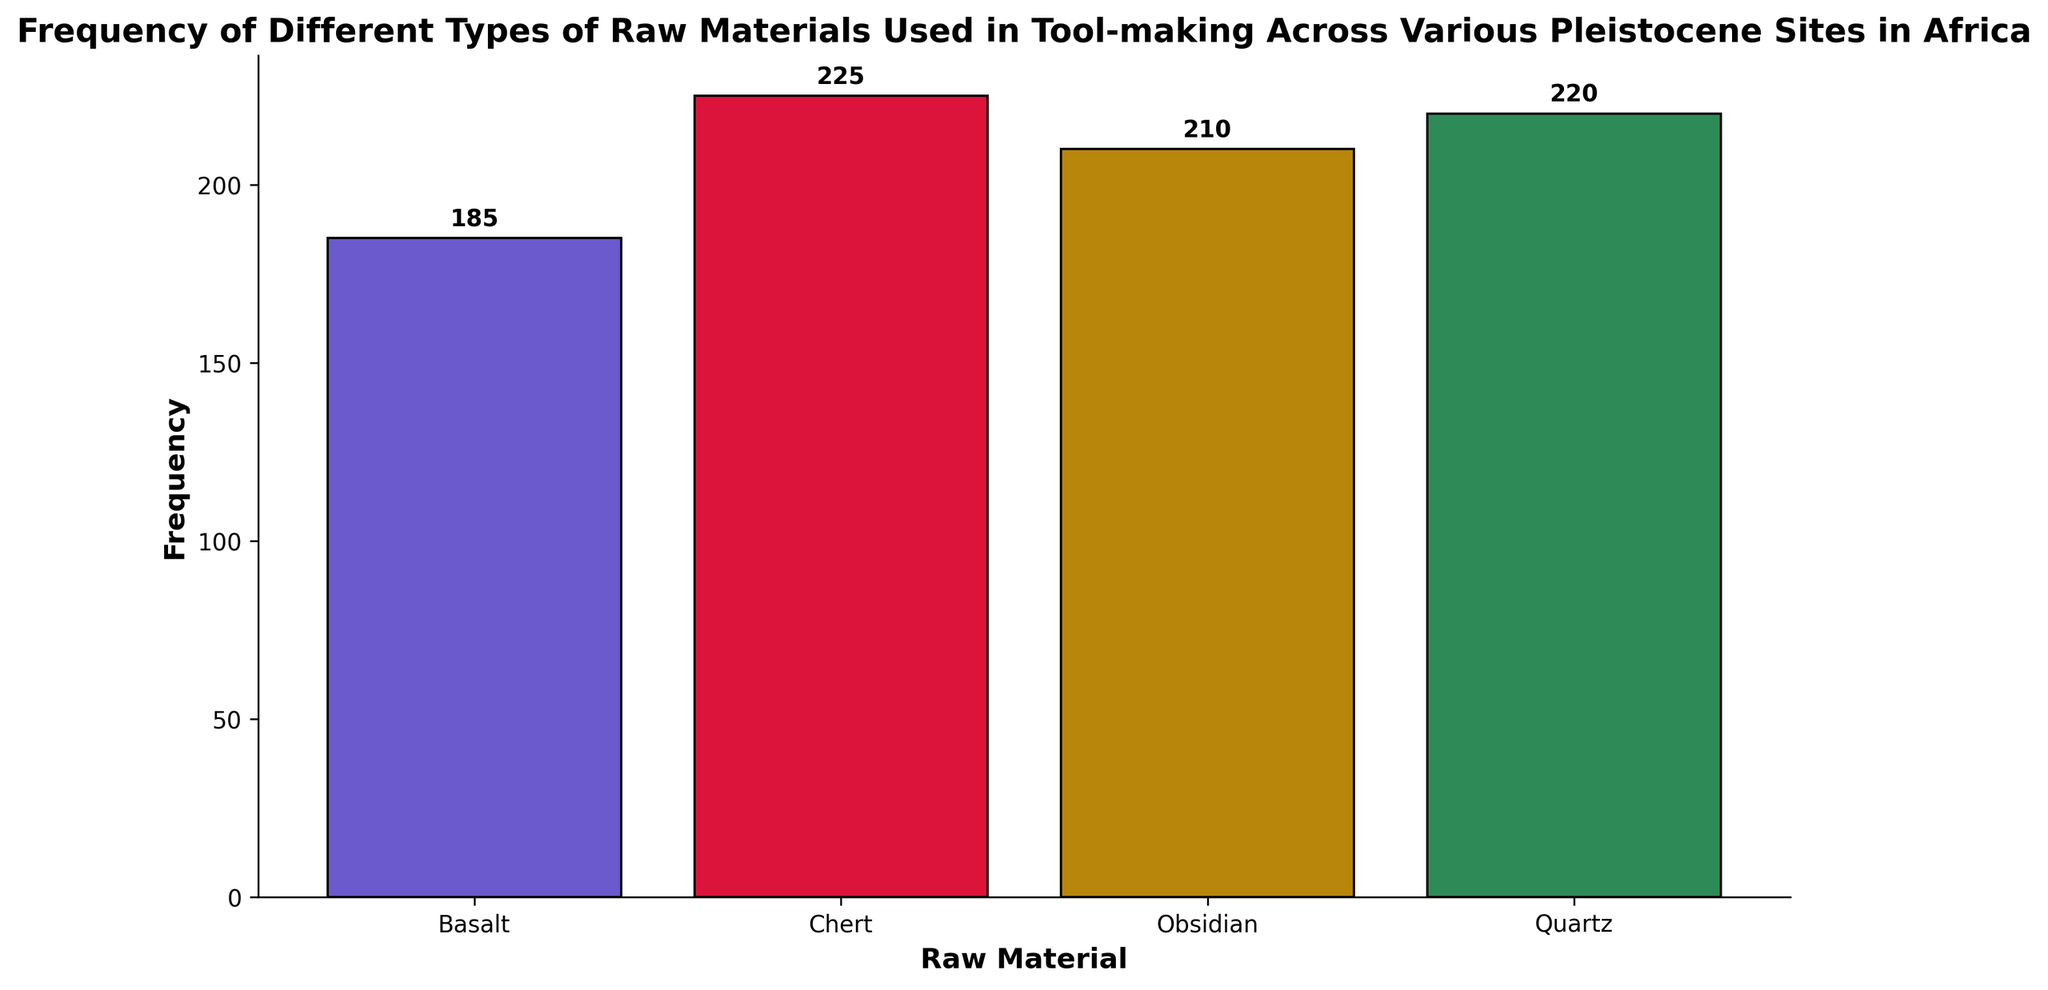What is the total frequency of Chert used across all sites? To find the total frequency of Chert, we sum up the Chert values from each site: 45 (Olduvai Gorge) + 50 (Koobi Fora) + 25 (Gademotta) + 30 (Dmanisi) + 40 (Blombos Cave) + 35 (Wonderwerk Cave). The result is 225.
Answer: 225 Which raw material has the highest frequency overall? Reviewing the heights of the bars representing each raw material, Obsidian has the highest overall frequency with the tallest bar at 210.
Answer: Obsidian How many more times is Obsidian used compared to Quartz? Obsidian's frequency is 210, and Quartz's frequency is 220. However, this is slightly less than Quartz, meaning Quartz is used more than Obsidian by 10 units.
Answer: Quartz has a frequency 10 units higher By how much is the frequency of Basalt greater in Dmanisi compared to Gademotta? From the histogram, we see that Dmanisi has a Basalt frequency of 40 and Gademotta has 20. Subtracting these values, we find that Basalt usage in Dmanisi is greater by 20 units.
Answer: 20 What is the average frequency of types of raw materials used in Gademotta? Summing the frequencies of Chert (25), Obsidian (55), Quartz (45), and Basalt (20) in Gademotta gives a total of 145. Dividing this total by the number of raw materials (4) gives an average of 36.25.
Answer: 36.25 Which site uses the least amount of Obsidian, and what is its frequency? By inspecting the histogram, Blombos Cave has the shortest bar for Obsidian with a frequency of 20, the least among the sites.
Answer: Blombos Cave, 20 What is the difference in frequency between the most and least used raw materials? The most used material is Quartz with a frequency of 220, and the least used is Basalt with a frequency of 185. The difference is 220 - 185 = 35 units.
Answer: 35 What is the combined frequency of Quartz and Obsidian? By adding the total frequencies of Quartz (220) and Obsidian (210), we find the combined frequency is 430.
Answer: 430 Which raw material has the second highest overall usage? The histogram bars indicate that Quartz has the highest frequency (220), making Obsidian (210) the second highest.
Answer: Obsidian Is the frequency of Quartz higher in Blombos Cave than in Olduvai Gorge? Yes, according to the histogram, Quartz frequency in Blombos Cave (50) is higher than in Olduvai Gorge (20).
Answer: Yes 